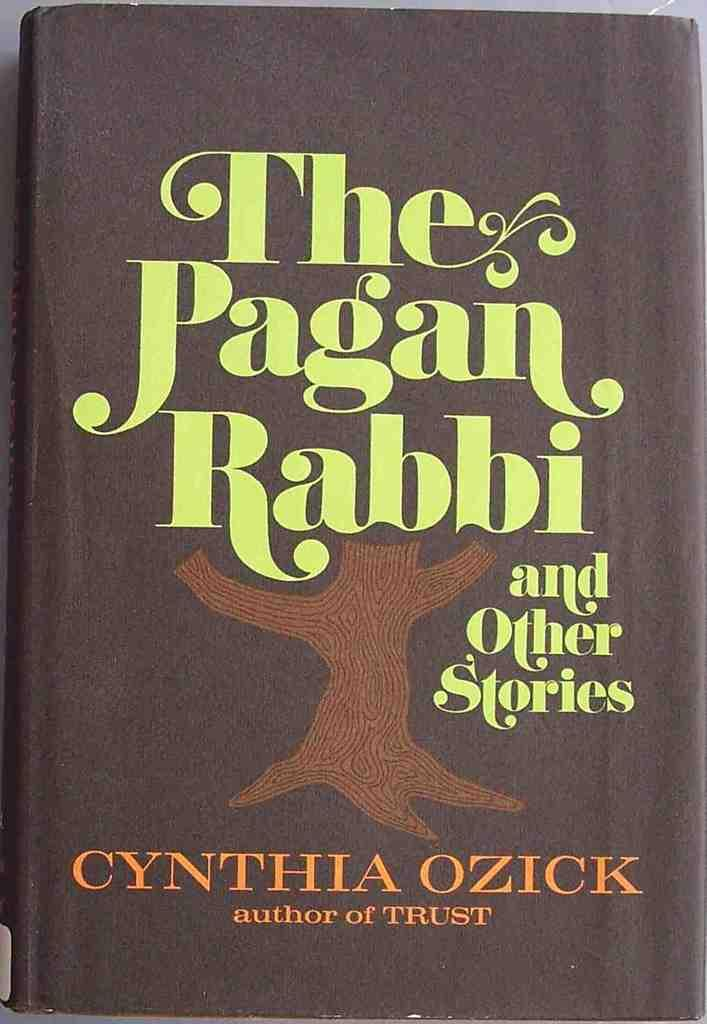<image>
Give a short and clear explanation of the subsequent image. A book by Cynthia Ozick has a tree trunk on the front. 